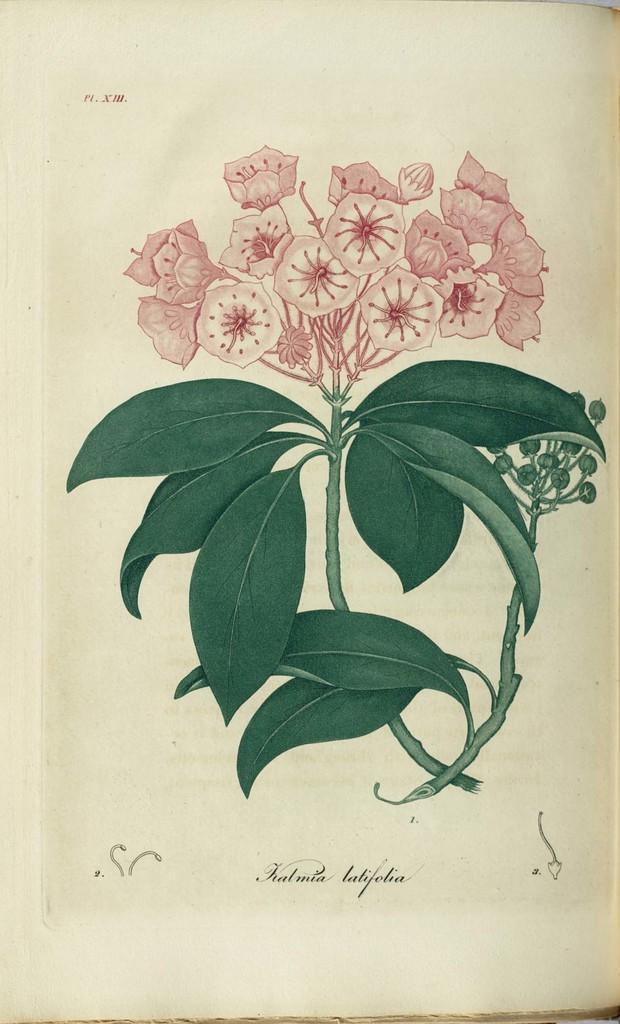Could you give a brief overview of what you see in this image? In the center of the picture we can see the drawing of a plant with the green leaves and pink color flowers. At the bottom there is a text on the image. 